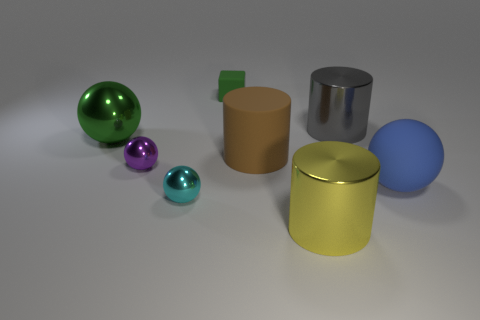Add 2 blue matte things. How many objects exist? 10 Subtract all blocks. How many objects are left? 7 Subtract all big purple cylinders. Subtract all brown objects. How many objects are left? 7 Add 5 small cyan spheres. How many small cyan spheres are left? 6 Add 8 green shiny things. How many green shiny things exist? 9 Subtract 0 purple cubes. How many objects are left? 8 